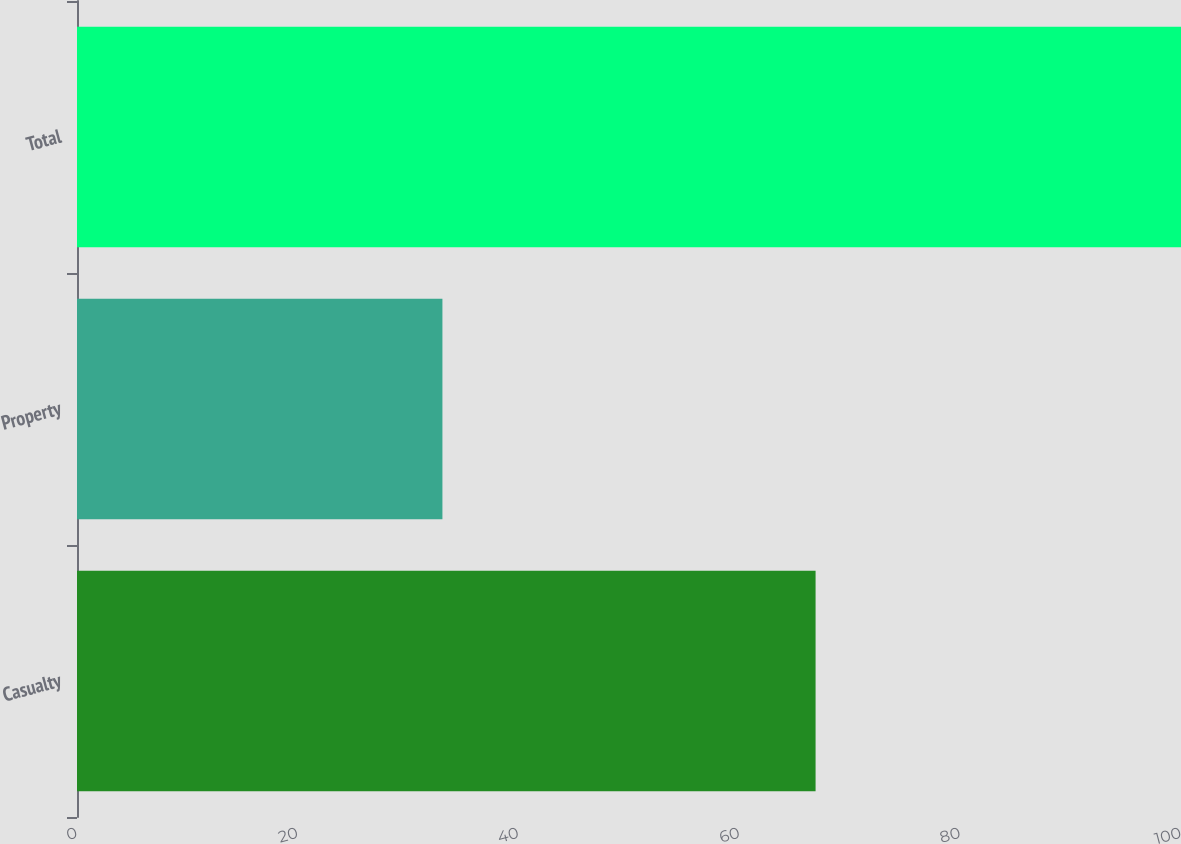Convert chart to OTSL. <chart><loc_0><loc_0><loc_500><loc_500><bar_chart><fcel>Casualty<fcel>Property<fcel>Total<nl><fcel>66.9<fcel>33.1<fcel>100<nl></chart> 